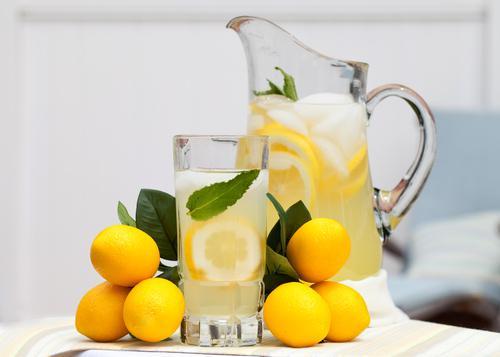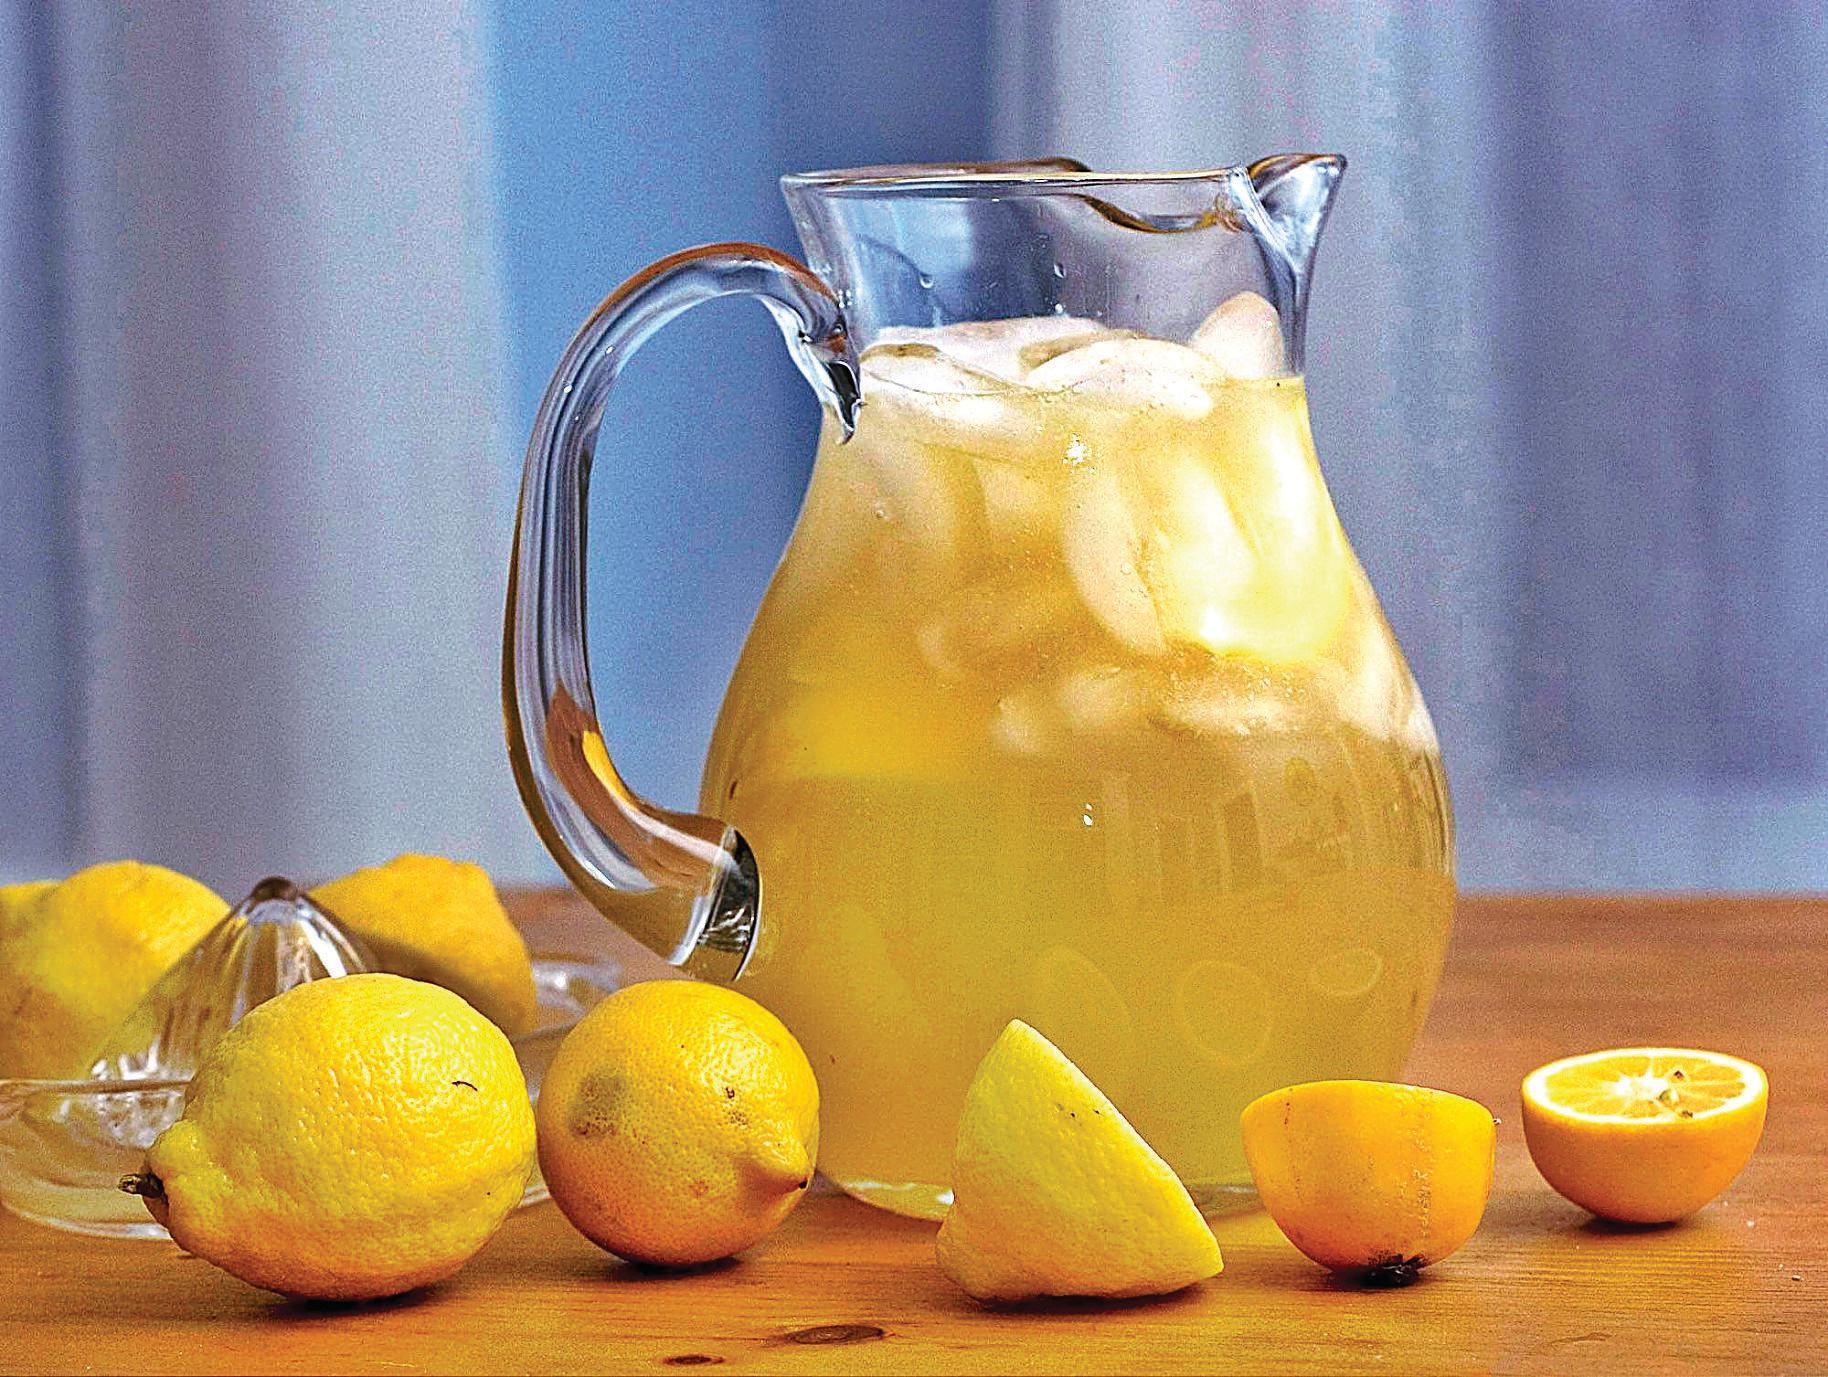The first image is the image on the left, the second image is the image on the right. Evaluate the accuracy of this statement regarding the images: "The left image includes lemons and a beverage in a drinking glass in front of a pitcher, and the right image includes a pitcher with a rounded bottom.". Is it true? Answer yes or no. Yes. The first image is the image on the left, the second image is the image on the right. Examine the images to the left and right. Is the description "In at least one image there is a lemon in front of a rounded lemonade pitcher." accurate? Answer yes or no. Yes. 